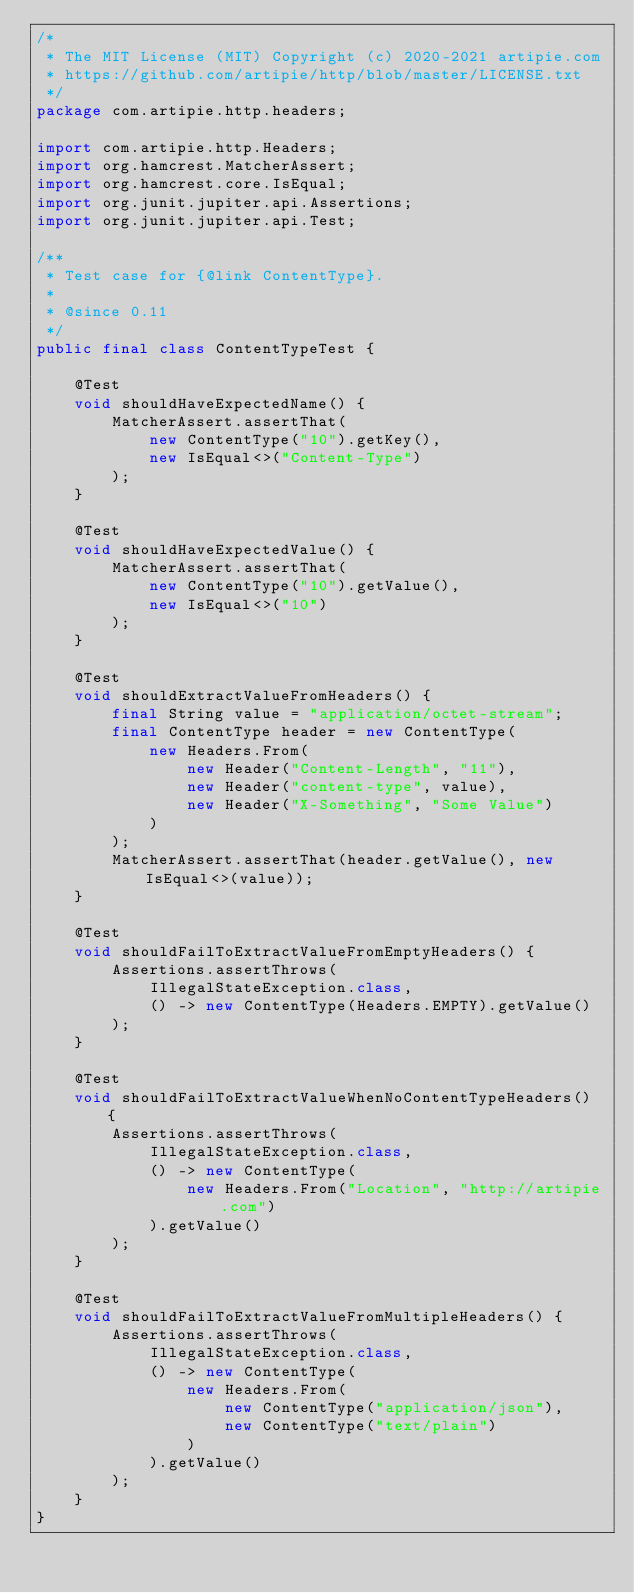Convert code to text. <code><loc_0><loc_0><loc_500><loc_500><_Java_>/*
 * The MIT License (MIT) Copyright (c) 2020-2021 artipie.com
 * https://github.com/artipie/http/blob/master/LICENSE.txt
 */
package com.artipie.http.headers;

import com.artipie.http.Headers;
import org.hamcrest.MatcherAssert;
import org.hamcrest.core.IsEqual;
import org.junit.jupiter.api.Assertions;
import org.junit.jupiter.api.Test;

/**
 * Test case for {@link ContentType}.
 *
 * @since 0.11
 */
public final class ContentTypeTest {

    @Test
    void shouldHaveExpectedName() {
        MatcherAssert.assertThat(
            new ContentType("10").getKey(),
            new IsEqual<>("Content-Type")
        );
    }

    @Test
    void shouldHaveExpectedValue() {
        MatcherAssert.assertThat(
            new ContentType("10").getValue(),
            new IsEqual<>("10")
        );
    }

    @Test
    void shouldExtractValueFromHeaders() {
        final String value = "application/octet-stream";
        final ContentType header = new ContentType(
            new Headers.From(
                new Header("Content-Length", "11"),
                new Header("content-type", value),
                new Header("X-Something", "Some Value")
            )
        );
        MatcherAssert.assertThat(header.getValue(), new IsEqual<>(value));
    }

    @Test
    void shouldFailToExtractValueFromEmptyHeaders() {
        Assertions.assertThrows(
            IllegalStateException.class,
            () -> new ContentType(Headers.EMPTY).getValue()
        );
    }

    @Test
    void shouldFailToExtractValueWhenNoContentTypeHeaders() {
        Assertions.assertThrows(
            IllegalStateException.class,
            () -> new ContentType(
                new Headers.From("Location", "http://artipie.com")
            ).getValue()
        );
    }

    @Test
    void shouldFailToExtractValueFromMultipleHeaders() {
        Assertions.assertThrows(
            IllegalStateException.class,
            () -> new ContentType(
                new Headers.From(
                    new ContentType("application/json"),
                    new ContentType("text/plain")
                )
            ).getValue()
        );
    }
}
</code> 